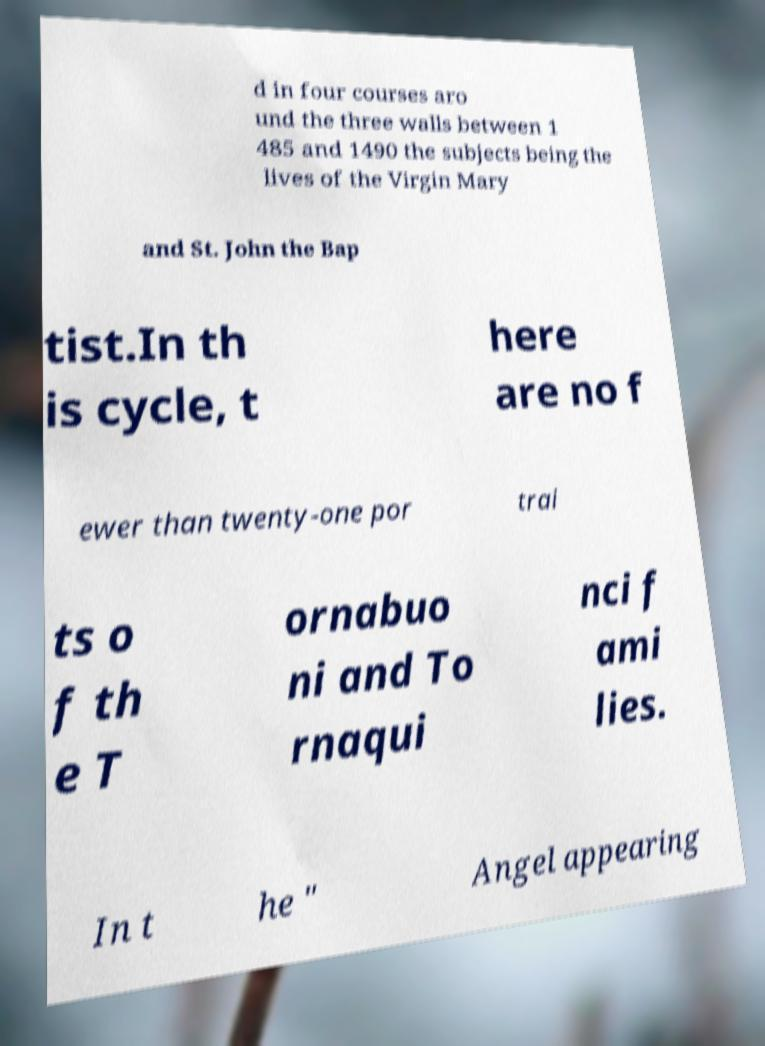There's text embedded in this image that I need extracted. Can you transcribe it verbatim? d in four courses aro und the three walls between 1 485 and 1490 the subjects being the lives of the Virgin Mary and St. John the Bap tist.In th is cycle, t here are no f ewer than twenty-one por trai ts o f th e T ornabuo ni and To rnaqui nci f ami lies. In t he " Angel appearing 